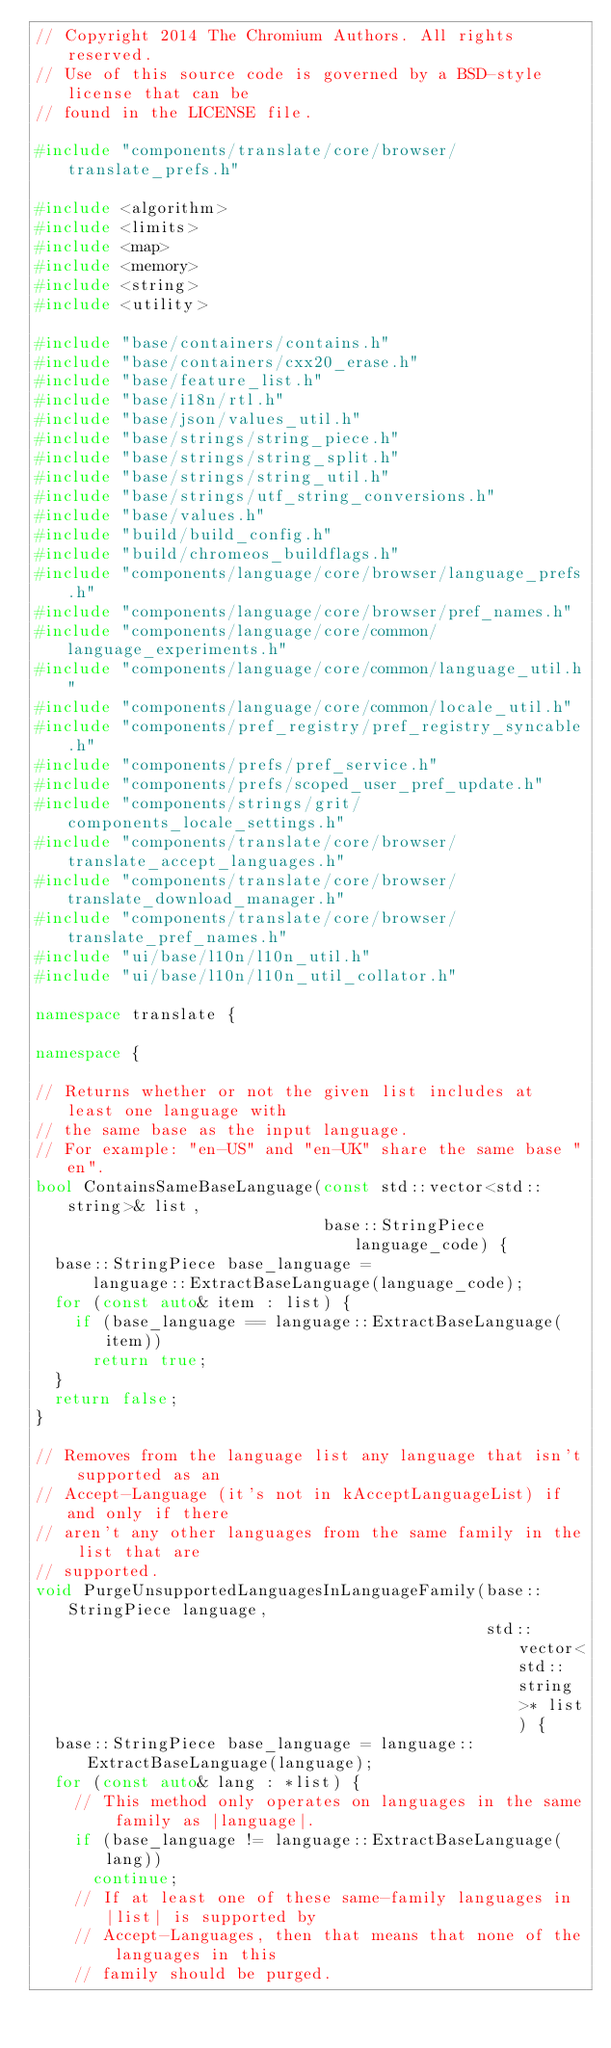Convert code to text. <code><loc_0><loc_0><loc_500><loc_500><_C++_>// Copyright 2014 The Chromium Authors. All rights reserved.
// Use of this source code is governed by a BSD-style license that can be
// found in the LICENSE file.

#include "components/translate/core/browser/translate_prefs.h"

#include <algorithm>
#include <limits>
#include <map>
#include <memory>
#include <string>
#include <utility>

#include "base/containers/contains.h"
#include "base/containers/cxx20_erase.h"
#include "base/feature_list.h"
#include "base/i18n/rtl.h"
#include "base/json/values_util.h"
#include "base/strings/string_piece.h"
#include "base/strings/string_split.h"
#include "base/strings/string_util.h"
#include "base/strings/utf_string_conversions.h"
#include "base/values.h"
#include "build/build_config.h"
#include "build/chromeos_buildflags.h"
#include "components/language/core/browser/language_prefs.h"
#include "components/language/core/browser/pref_names.h"
#include "components/language/core/common/language_experiments.h"
#include "components/language/core/common/language_util.h"
#include "components/language/core/common/locale_util.h"
#include "components/pref_registry/pref_registry_syncable.h"
#include "components/prefs/pref_service.h"
#include "components/prefs/scoped_user_pref_update.h"
#include "components/strings/grit/components_locale_settings.h"
#include "components/translate/core/browser/translate_accept_languages.h"
#include "components/translate/core/browser/translate_download_manager.h"
#include "components/translate/core/browser/translate_pref_names.h"
#include "ui/base/l10n/l10n_util.h"
#include "ui/base/l10n/l10n_util_collator.h"

namespace translate {

namespace {

// Returns whether or not the given list includes at least one language with
// the same base as the input language.
// For example: "en-US" and "en-UK" share the same base "en".
bool ContainsSameBaseLanguage(const std::vector<std::string>& list,
                              base::StringPiece language_code) {
  base::StringPiece base_language =
      language::ExtractBaseLanguage(language_code);
  for (const auto& item : list) {
    if (base_language == language::ExtractBaseLanguage(item))
      return true;
  }
  return false;
}

// Removes from the language list any language that isn't supported as an
// Accept-Language (it's not in kAcceptLanguageList) if and only if there
// aren't any other languages from the same family in the list that are
// supported.
void PurgeUnsupportedLanguagesInLanguageFamily(base::StringPiece language,
                                               std::vector<std::string>* list) {
  base::StringPiece base_language = language::ExtractBaseLanguage(language);
  for (const auto& lang : *list) {
    // This method only operates on languages in the same family as |language|.
    if (base_language != language::ExtractBaseLanguage(lang))
      continue;
    // If at least one of these same-family languages in |list| is supported by
    // Accept-Languages, then that means that none of the languages in this
    // family should be purged.</code> 